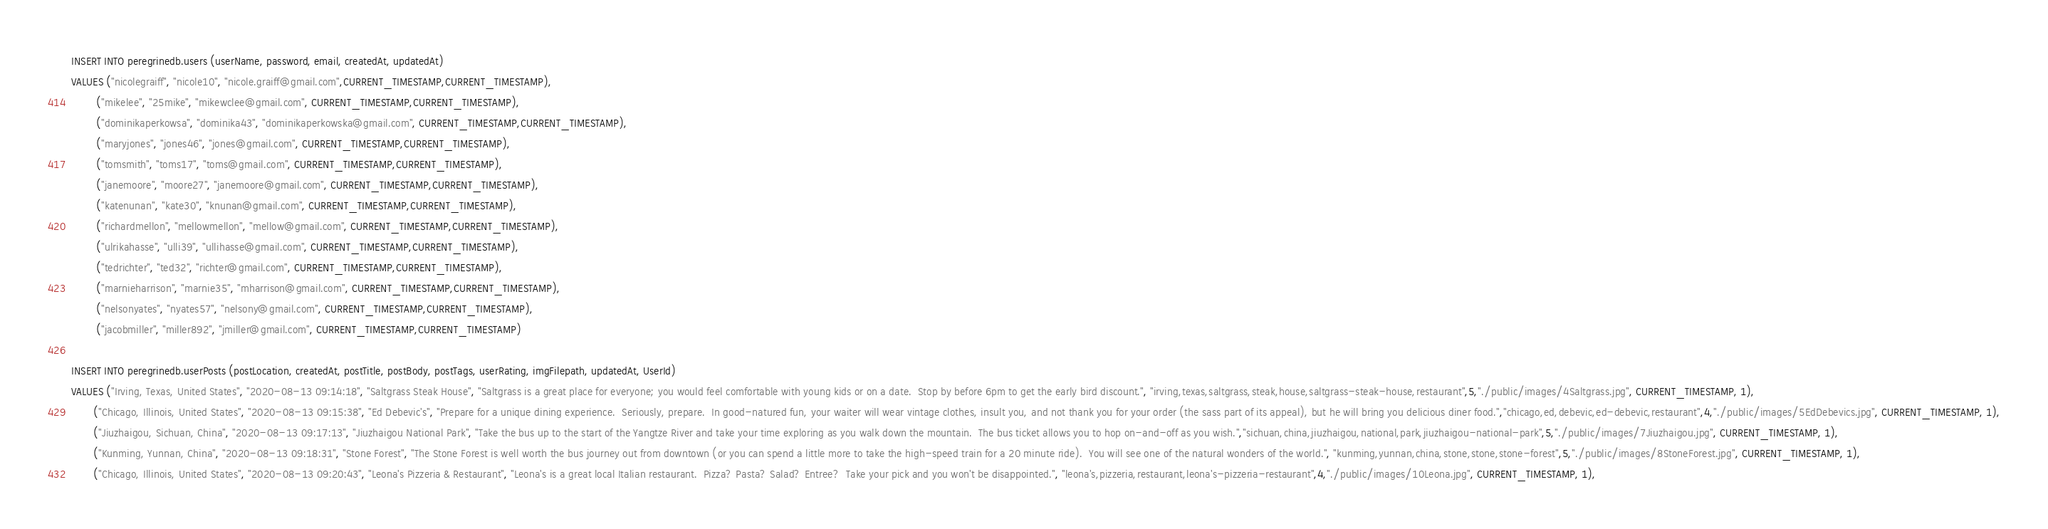<code> <loc_0><loc_0><loc_500><loc_500><_SQL_>
INSERT INTO peregrinedb.users (userName, password, email, createdAt, updatedAt)
VALUES ("nicolegraiff", "nicole10", "nicole.graiff@gmail.com",CURRENT_TIMESTAMP,CURRENT_TIMESTAMP),
        ("mikelee", "25mike", "mikewclee@gmail.com", CURRENT_TIMESTAMP,CURRENT_TIMESTAMP),
        ("dominikaperkowsa", "dominika43", "dominikaperkowska@gmail.com", CURRENT_TIMESTAMP,CURRENT_TIMESTAMP),
        ("maryjones", "jones46", "jones@gmail.com", CURRENT_TIMESTAMP,CURRENT_TIMESTAMP),
        ("tomsmith", "toms17", "toms@gmail.com", CURRENT_TIMESTAMP,CURRENT_TIMESTAMP),
        ("janemoore", "moore27", "janemoore@gmail.com", CURRENT_TIMESTAMP,CURRENT_TIMESTAMP),
        ("katenunan", "kate30", "knunan@gmail.com", CURRENT_TIMESTAMP,CURRENT_TIMESTAMP),
        ("richardmellon", "mellowmellon", "mellow@gmail.com", CURRENT_TIMESTAMP,CURRENT_TIMESTAMP),
        ("ulrikahasse", "ulli39", "ullihasse@gmail.com", CURRENT_TIMESTAMP,CURRENT_TIMESTAMP),
        ("tedrichter", "ted32", "richter@gmail.com", CURRENT_TIMESTAMP,CURRENT_TIMESTAMP),
        ("marnieharrison", "marnie35", "mharrison@gmail.com", CURRENT_TIMESTAMP,CURRENT_TIMESTAMP),
        ("nelsonyates", "nyates57", "nelsony@gmail.com", CURRENT_TIMESTAMP,CURRENT_TIMESTAMP),
        ("jacobmiller", "miller892", "jmiller@gmail.com", CURRENT_TIMESTAMP,CURRENT_TIMESTAMP)

INSERT INTO peregrinedb.userPosts (postLocation, createdAt, postTitle, postBody, postTags, userRating, imgFilepath, updatedAt, UserId)
VALUES ("Irving, Texas, United States", "2020-08-13 09:14:18", "Saltgrass Steak House", "Saltgrass is a great place for everyone; you would feel comfortable with young kids or on a date.  Stop by before 6pm to get the early bird discount.", "irving,texas,saltgrass,steak,house,saltgrass-steak-house,restaurant",5,"./public/images/4Saltgrass.jpg", CURRENT_TIMESTAMP, 1),
       ("Chicago, Illinois, United States", "2020-08-13 09:15:38", "Ed Debevic's", "Prepare for a unique dining experience.  Seriously, prepare.  In good-natured fun, your waiter will wear vintage clothes, insult you, and not thank you for your order (the sass part of its appeal), but he will bring you delicious diner food.","chicago,ed,debevic,ed-debevic,restaurant",4,"./public/images/5EdDebevics.jpg", CURRENT_TIMESTAMP, 1),
       ("Jiuzhaigou, Sichuan, China", "2020-08-13 09:17:13", "Jiuzhaigou National Park", "Take the bus up to the start of the Yangtze River and take your time exploring as you walk down the mountain.  The bus ticket allows you to hop on-and-off as you wish.","sichuan,china,jiuzhaigou,national,park,jiuzhaigou-national-park",5,"./public/images/7Jiuzhaigou.jpg", CURRENT_TIMESTAMP, 1),
       ("Kunming, Yunnan, China", "2020-08-13 09:18:31", "Stone Forest", "The Stone Forest is well worth the bus journey out from downtown (or you can spend a little more to take the high-speed train for a 20 minute ride).  You will see one of the natural wonders of the world.", "kunming,yunnan,china,stone,stone,stone-forest",5,"./public/images/8StoneForest.jpg", CURRENT_TIMESTAMP, 1),
       ("Chicago, Illinois, United States", "2020-08-13 09:20:43", "Leona's Pizzeria & Restaurant", "Leona's is a great local Italian restaurant.  Pizza? Pasta? Salad? Entree?  Take your pick and you won't be disappointed.", "leona's,pizzeria,restaurant,leona's-pizzeria-restaurant",4,"./public/images/10Leona.jpg", CURRENT_TIMESTAMP, 1),</code> 